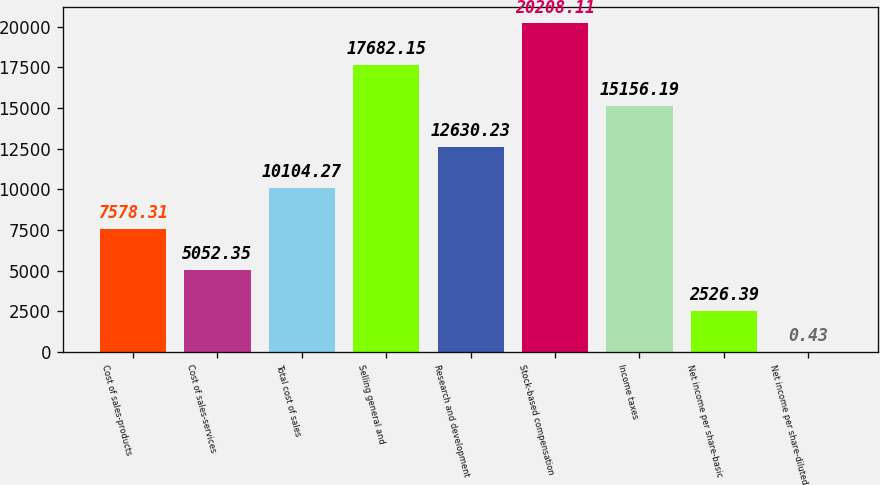<chart> <loc_0><loc_0><loc_500><loc_500><bar_chart><fcel>Cost of sales-products<fcel>Cost of sales-services<fcel>Total cost of sales<fcel>Selling general and<fcel>Research and development<fcel>Stock-based compensation<fcel>Income taxes<fcel>Net income per share-basic<fcel>Net income per share-diluted<nl><fcel>7578.31<fcel>5052.35<fcel>10104.3<fcel>17682.2<fcel>12630.2<fcel>20208.1<fcel>15156.2<fcel>2526.39<fcel>0.43<nl></chart> 